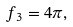<formula> <loc_0><loc_0><loc_500><loc_500>f _ { 3 } = 4 \pi ,</formula> 